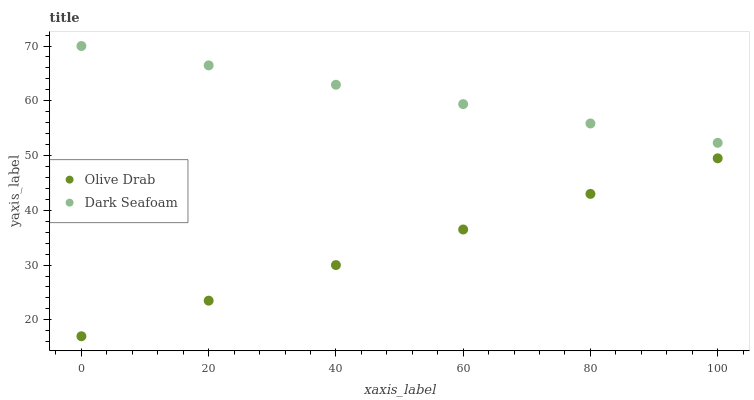Does Olive Drab have the minimum area under the curve?
Answer yes or no. Yes. Does Dark Seafoam have the maximum area under the curve?
Answer yes or no. Yes. Does Olive Drab have the maximum area under the curve?
Answer yes or no. No. Is Olive Drab the smoothest?
Answer yes or no. Yes. Is Dark Seafoam the roughest?
Answer yes or no. Yes. Is Olive Drab the roughest?
Answer yes or no. No. Does Olive Drab have the lowest value?
Answer yes or no. Yes. Does Dark Seafoam have the highest value?
Answer yes or no. Yes. Does Olive Drab have the highest value?
Answer yes or no. No. Is Olive Drab less than Dark Seafoam?
Answer yes or no. Yes. Is Dark Seafoam greater than Olive Drab?
Answer yes or no. Yes. Does Olive Drab intersect Dark Seafoam?
Answer yes or no. No. 